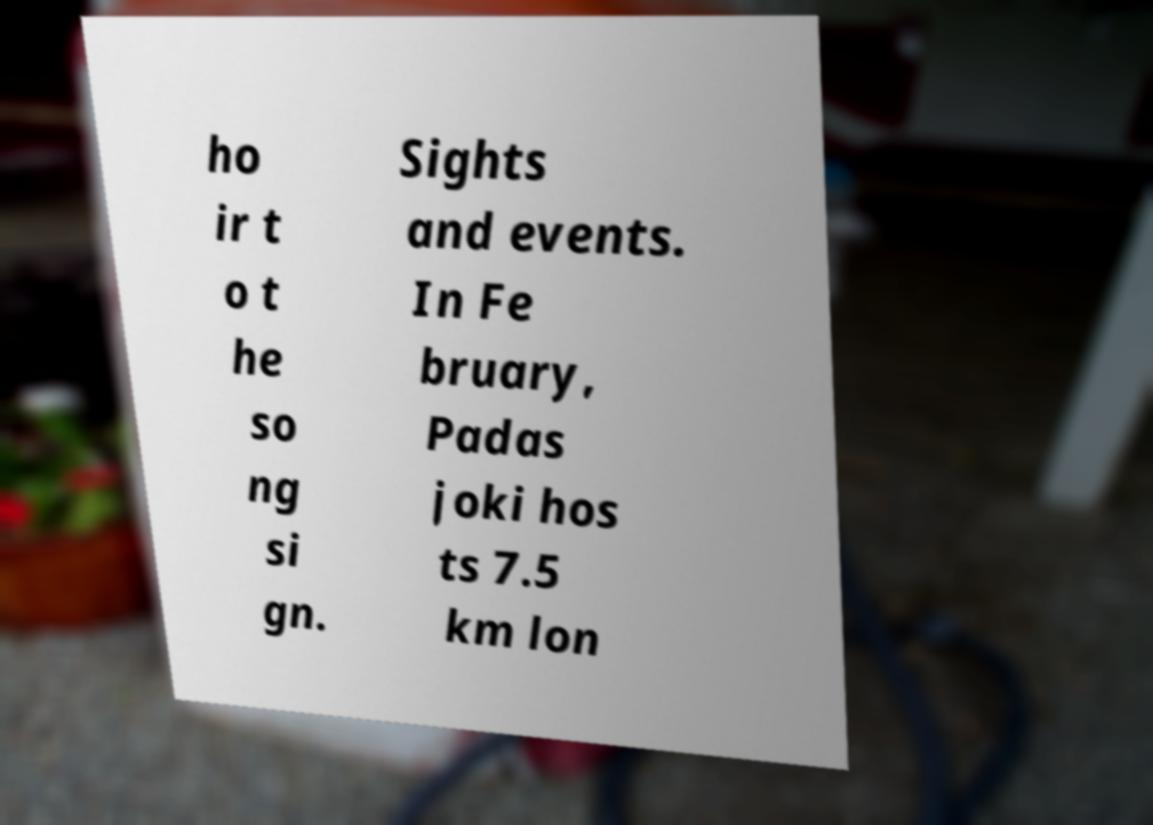I need the written content from this picture converted into text. Can you do that? ho ir t o t he so ng si gn. Sights and events. In Fe bruary, Padas joki hos ts 7.5 km lon 